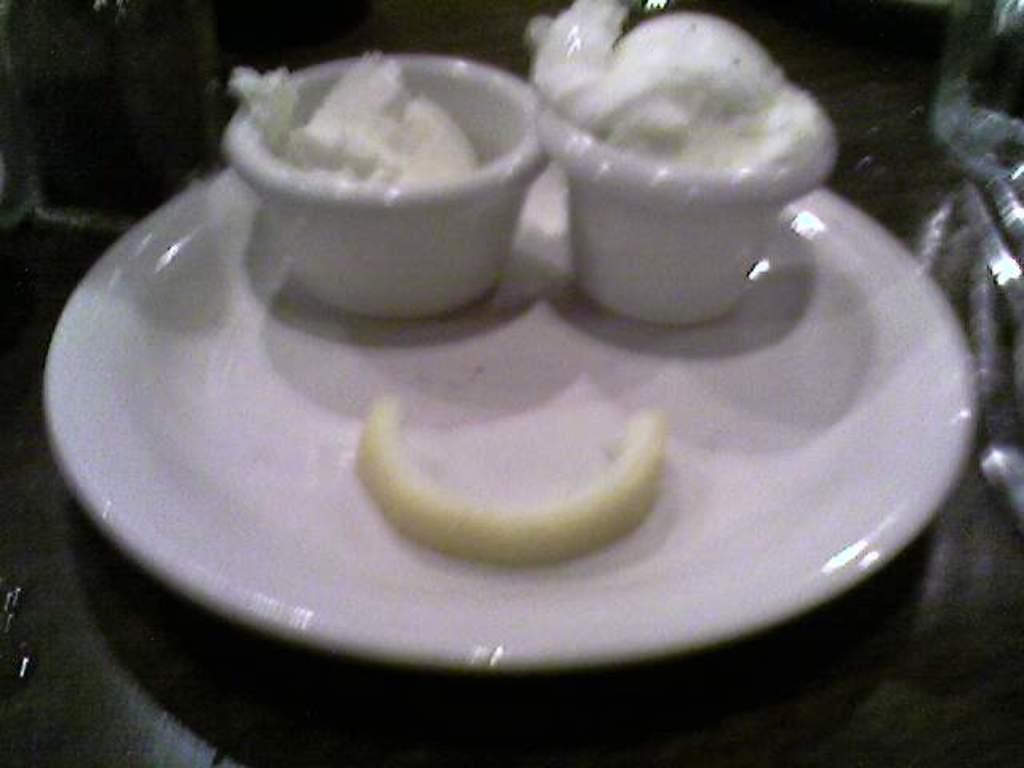What is present on the plate in the image? There is a plate in the image, and it has bowls with food items on it. Can you describe the food items on the plate? Unfortunately, the specific food items cannot be determined from the provided facts. Is there anything else on the plate besides the bowls with food items? Yes, there is an additional item on the plate. What type of shirt is the expert wearing in the image? There is no expert or shirt present in the image; it only features a plate with bowls and an additional item. 